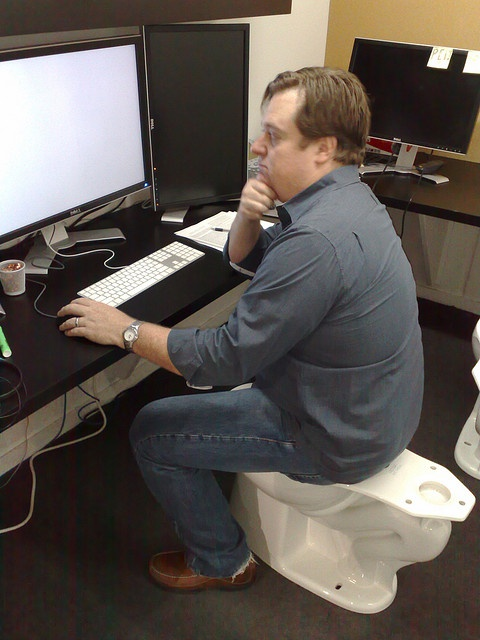Describe the objects in this image and their specific colors. I can see people in black and gray tones, tv in black, lavender, gray, and darkgray tones, toilet in black, darkgray, ivory, tan, and gray tones, tv in black, olive, maroon, and darkgray tones, and keyboard in black, ivory, darkgray, and lightgray tones in this image. 